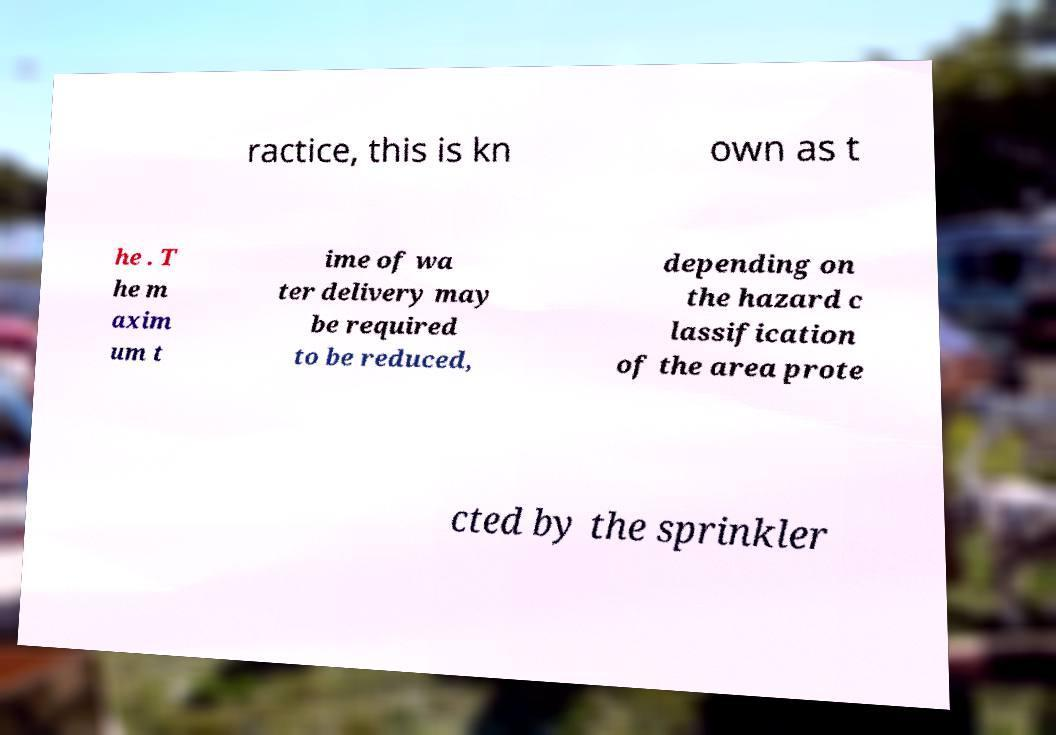Please identify and transcribe the text found in this image. ractice, this is kn own as t he . T he m axim um t ime of wa ter delivery may be required to be reduced, depending on the hazard c lassification of the area prote cted by the sprinkler 